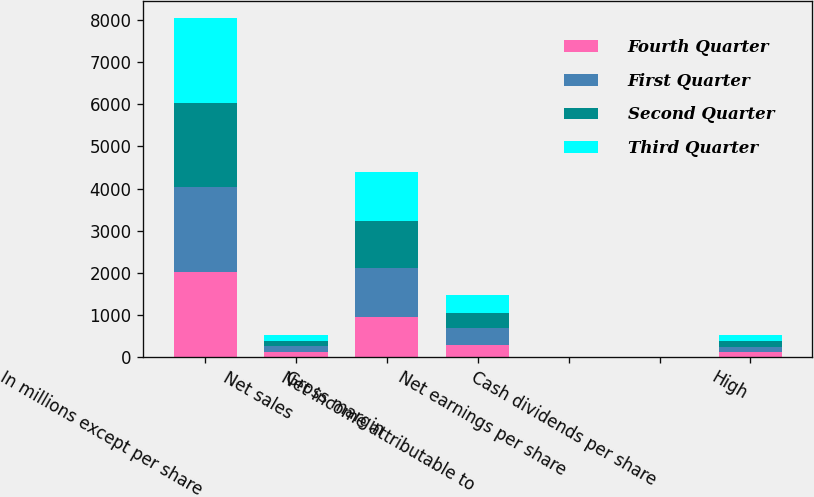Convert chart. <chart><loc_0><loc_0><loc_500><loc_500><stacked_bar_chart><ecel><fcel>In millions except per share<fcel>Net sales<fcel>Gross margin<fcel>Net income attributable to<fcel>Net earnings per share<fcel>Cash dividends per share<fcel>High<nl><fcel>Fourth Quarter<fcel>2013<fcel>129.52<fcel>957<fcel>282<fcel>1.49<fcel>0.5<fcel>122.54<nl><fcel>First Quarter<fcel>2013<fcel>129.52<fcel>1153<fcel>414<fcel>2.2<fcel>0.5<fcel>122.32<nl><fcel>Second Quarter<fcel>2013<fcel>129.52<fcel>1109<fcel>355<fcel>1.9<fcel>0.62<fcel>136.5<nl><fcel>Third Quarter<fcel>2013<fcel>129.52<fcel>1164<fcel>432<fcel>2.32<fcel>0.62<fcel>141.39<nl></chart> 